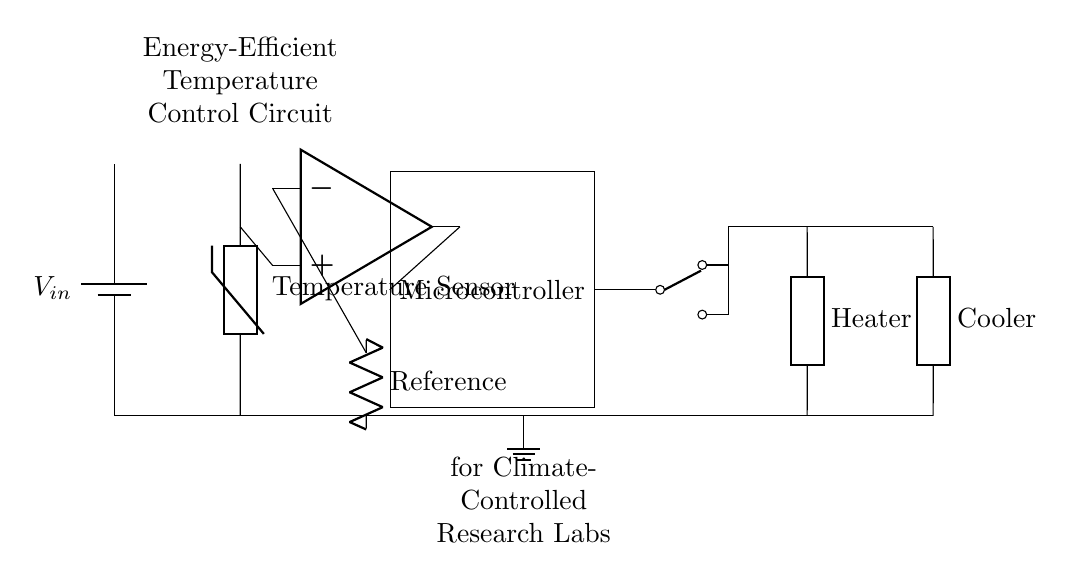What type of components are used in this circuit? The circuit contains a battery, a thermistor, an operational amplifier, a microcontroller, a relay, a heater, and a cooler. These components are specifically chosen for their roles in a temperature control system.
Answer: thermistor, operational amplifier, microcontroller, relay, heater, cooler What is the role of the microcontroller in this circuit? The microcontroller processes the information received from the temperature sensor (thermistor) and decides whether to activate the heating or cooling elements based on the temperature readings relative to the reference value.
Answer: control temperature How many outputs does the relay have in this circuit? The relay is shown to have two outputs that direct the operation to either the heating or cooling elements, allowing for switching between the two based on microcontroller commands.
Answer: two outputs What does the reference component do in this circuit? The reference component sets a target temperature against which the output from the thermistor is compared. The comparator uses this reference to determine if the current temperature requires heating or cooling actions.
Answer: sets target temperature What happens to the heating and cooling elements when the temperature exceeds the reference? If the temperature exceeds the reference, the microcontroller will deactivate the heating element and activate the cooling element through the relay, responding to the observed temperature change.
Answer: cooling element activates, heating element deactivates What is the primary purpose of the entire circuit? The entire circuit is designed to maintain an energy-efficient temperature control system for climate-controlled research labs, optimizing temperature for sensitive research applications.
Answer: maintain temperature control What type of sensor is represented in this circuit? The sensor used in this circuit is a thermistor, which detects changes in temperature and provides input to the circuit for temperature regulation.
Answer: thermistor 